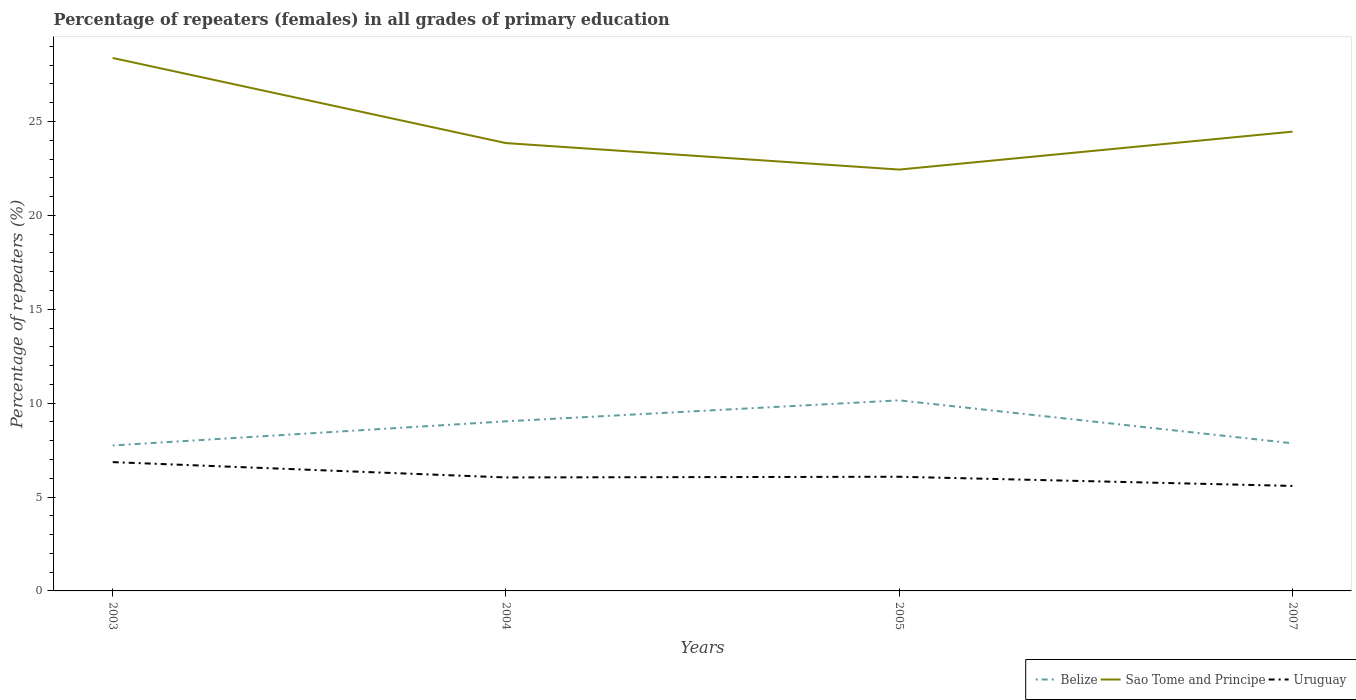How many different coloured lines are there?
Keep it short and to the point. 3. Is the number of lines equal to the number of legend labels?
Make the answer very short. Yes. Across all years, what is the maximum percentage of repeaters (females) in Sao Tome and Principe?
Give a very brief answer. 22.44. What is the total percentage of repeaters (females) in Belize in the graph?
Your response must be concise. -2.4. What is the difference between the highest and the second highest percentage of repeaters (females) in Sao Tome and Principe?
Keep it short and to the point. 5.94. What is the difference between the highest and the lowest percentage of repeaters (females) in Sao Tome and Principe?
Offer a very short reply. 1. Is the percentage of repeaters (females) in Sao Tome and Principe strictly greater than the percentage of repeaters (females) in Uruguay over the years?
Offer a terse response. No. How many lines are there?
Your answer should be very brief. 3. How many years are there in the graph?
Your response must be concise. 4. Does the graph contain any zero values?
Provide a short and direct response. No. Does the graph contain grids?
Offer a very short reply. No. Where does the legend appear in the graph?
Offer a terse response. Bottom right. How many legend labels are there?
Your response must be concise. 3. What is the title of the graph?
Keep it short and to the point. Percentage of repeaters (females) in all grades of primary education. Does "Armenia" appear as one of the legend labels in the graph?
Your answer should be very brief. No. What is the label or title of the X-axis?
Give a very brief answer. Years. What is the label or title of the Y-axis?
Offer a very short reply. Percentage of repeaters (%). What is the Percentage of repeaters (%) of Belize in 2003?
Provide a short and direct response. 7.75. What is the Percentage of repeaters (%) in Sao Tome and Principe in 2003?
Keep it short and to the point. 28.38. What is the Percentage of repeaters (%) of Uruguay in 2003?
Give a very brief answer. 6.86. What is the Percentage of repeaters (%) of Belize in 2004?
Offer a terse response. 9.03. What is the Percentage of repeaters (%) in Sao Tome and Principe in 2004?
Keep it short and to the point. 23.85. What is the Percentage of repeaters (%) of Uruguay in 2004?
Provide a succinct answer. 6.04. What is the Percentage of repeaters (%) in Belize in 2005?
Keep it short and to the point. 10.15. What is the Percentage of repeaters (%) in Sao Tome and Principe in 2005?
Your response must be concise. 22.44. What is the Percentage of repeaters (%) in Uruguay in 2005?
Your answer should be compact. 6.08. What is the Percentage of repeaters (%) of Belize in 2007?
Offer a very short reply. 7.86. What is the Percentage of repeaters (%) of Sao Tome and Principe in 2007?
Offer a terse response. 24.46. What is the Percentage of repeaters (%) in Uruguay in 2007?
Your answer should be compact. 5.59. Across all years, what is the maximum Percentage of repeaters (%) in Belize?
Ensure brevity in your answer.  10.15. Across all years, what is the maximum Percentage of repeaters (%) in Sao Tome and Principe?
Ensure brevity in your answer.  28.38. Across all years, what is the maximum Percentage of repeaters (%) in Uruguay?
Offer a terse response. 6.86. Across all years, what is the minimum Percentage of repeaters (%) of Belize?
Your answer should be very brief. 7.75. Across all years, what is the minimum Percentage of repeaters (%) of Sao Tome and Principe?
Offer a very short reply. 22.44. Across all years, what is the minimum Percentage of repeaters (%) of Uruguay?
Your answer should be compact. 5.59. What is the total Percentage of repeaters (%) of Belize in the graph?
Give a very brief answer. 34.79. What is the total Percentage of repeaters (%) in Sao Tome and Principe in the graph?
Provide a succinct answer. 99.13. What is the total Percentage of repeaters (%) in Uruguay in the graph?
Offer a very short reply. 24.57. What is the difference between the Percentage of repeaters (%) of Belize in 2003 and that in 2004?
Keep it short and to the point. -1.29. What is the difference between the Percentage of repeaters (%) in Sao Tome and Principe in 2003 and that in 2004?
Offer a terse response. 4.53. What is the difference between the Percentage of repeaters (%) in Uruguay in 2003 and that in 2004?
Offer a very short reply. 0.82. What is the difference between the Percentage of repeaters (%) in Belize in 2003 and that in 2005?
Keep it short and to the point. -2.4. What is the difference between the Percentage of repeaters (%) of Sao Tome and Principe in 2003 and that in 2005?
Ensure brevity in your answer.  5.94. What is the difference between the Percentage of repeaters (%) of Uruguay in 2003 and that in 2005?
Provide a short and direct response. 0.78. What is the difference between the Percentage of repeaters (%) in Belize in 2003 and that in 2007?
Your answer should be compact. -0.11. What is the difference between the Percentage of repeaters (%) of Sao Tome and Principe in 2003 and that in 2007?
Your answer should be very brief. 3.92. What is the difference between the Percentage of repeaters (%) of Uruguay in 2003 and that in 2007?
Provide a succinct answer. 1.27. What is the difference between the Percentage of repeaters (%) in Belize in 2004 and that in 2005?
Your answer should be compact. -1.12. What is the difference between the Percentage of repeaters (%) in Sao Tome and Principe in 2004 and that in 2005?
Ensure brevity in your answer.  1.41. What is the difference between the Percentage of repeaters (%) in Uruguay in 2004 and that in 2005?
Offer a terse response. -0.04. What is the difference between the Percentage of repeaters (%) in Belize in 2004 and that in 2007?
Keep it short and to the point. 1.17. What is the difference between the Percentage of repeaters (%) in Sao Tome and Principe in 2004 and that in 2007?
Offer a terse response. -0.61. What is the difference between the Percentage of repeaters (%) of Uruguay in 2004 and that in 2007?
Give a very brief answer. 0.45. What is the difference between the Percentage of repeaters (%) in Belize in 2005 and that in 2007?
Keep it short and to the point. 2.29. What is the difference between the Percentage of repeaters (%) in Sao Tome and Principe in 2005 and that in 2007?
Offer a very short reply. -2.02. What is the difference between the Percentage of repeaters (%) of Uruguay in 2005 and that in 2007?
Your answer should be very brief. 0.49. What is the difference between the Percentage of repeaters (%) of Belize in 2003 and the Percentage of repeaters (%) of Sao Tome and Principe in 2004?
Make the answer very short. -16.1. What is the difference between the Percentage of repeaters (%) of Belize in 2003 and the Percentage of repeaters (%) of Uruguay in 2004?
Make the answer very short. 1.7. What is the difference between the Percentage of repeaters (%) in Sao Tome and Principe in 2003 and the Percentage of repeaters (%) in Uruguay in 2004?
Ensure brevity in your answer.  22.34. What is the difference between the Percentage of repeaters (%) of Belize in 2003 and the Percentage of repeaters (%) of Sao Tome and Principe in 2005?
Provide a succinct answer. -14.69. What is the difference between the Percentage of repeaters (%) of Belize in 2003 and the Percentage of repeaters (%) of Uruguay in 2005?
Ensure brevity in your answer.  1.67. What is the difference between the Percentage of repeaters (%) in Sao Tome and Principe in 2003 and the Percentage of repeaters (%) in Uruguay in 2005?
Provide a succinct answer. 22.3. What is the difference between the Percentage of repeaters (%) in Belize in 2003 and the Percentage of repeaters (%) in Sao Tome and Principe in 2007?
Provide a succinct answer. -16.71. What is the difference between the Percentage of repeaters (%) of Belize in 2003 and the Percentage of repeaters (%) of Uruguay in 2007?
Provide a short and direct response. 2.15. What is the difference between the Percentage of repeaters (%) of Sao Tome and Principe in 2003 and the Percentage of repeaters (%) of Uruguay in 2007?
Your answer should be very brief. 22.79. What is the difference between the Percentage of repeaters (%) of Belize in 2004 and the Percentage of repeaters (%) of Sao Tome and Principe in 2005?
Your response must be concise. -13.41. What is the difference between the Percentage of repeaters (%) in Belize in 2004 and the Percentage of repeaters (%) in Uruguay in 2005?
Offer a terse response. 2.95. What is the difference between the Percentage of repeaters (%) of Sao Tome and Principe in 2004 and the Percentage of repeaters (%) of Uruguay in 2005?
Keep it short and to the point. 17.77. What is the difference between the Percentage of repeaters (%) of Belize in 2004 and the Percentage of repeaters (%) of Sao Tome and Principe in 2007?
Offer a very short reply. -15.43. What is the difference between the Percentage of repeaters (%) in Belize in 2004 and the Percentage of repeaters (%) in Uruguay in 2007?
Your response must be concise. 3.44. What is the difference between the Percentage of repeaters (%) of Sao Tome and Principe in 2004 and the Percentage of repeaters (%) of Uruguay in 2007?
Your response must be concise. 18.26. What is the difference between the Percentage of repeaters (%) of Belize in 2005 and the Percentage of repeaters (%) of Sao Tome and Principe in 2007?
Make the answer very short. -14.31. What is the difference between the Percentage of repeaters (%) of Belize in 2005 and the Percentage of repeaters (%) of Uruguay in 2007?
Your answer should be very brief. 4.56. What is the difference between the Percentage of repeaters (%) of Sao Tome and Principe in 2005 and the Percentage of repeaters (%) of Uruguay in 2007?
Your response must be concise. 16.85. What is the average Percentage of repeaters (%) of Belize per year?
Make the answer very short. 8.7. What is the average Percentage of repeaters (%) of Sao Tome and Principe per year?
Provide a short and direct response. 24.78. What is the average Percentage of repeaters (%) of Uruguay per year?
Provide a succinct answer. 6.14. In the year 2003, what is the difference between the Percentage of repeaters (%) of Belize and Percentage of repeaters (%) of Sao Tome and Principe?
Ensure brevity in your answer.  -20.64. In the year 2003, what is the difference between the Percentage of repeaters (%) in Belize and Percentage of repeaters (%) in Uruguay?
Your answer should be compact. 0.89. In the year 2003, what is the difference between the Percentage of repeaters (%) in Sao Tome and Principe and Percentage of repeaters (%) in Uruguay?
Keep it short and to the point. 21.52. In the year 2004, what is the difference between the Percentage of repeaters (%) in Belize and Percentage of repeaters (%) in Sao Tome and Principe?
Your answer should be very brief. -14.82. In the year 2004, what is the difference between the Percentage of repeaters (%) of Belize and Percentage of repeaters (%) of Uruguay?
Keep it short and to the point. 2.99. In the year 2004, what is the difference between the Percentage of repeaters (%) in Sao Tome and Principe and Percentage of repeaters (%) in Uruguay?
Offer a terse response. 17.81. In the year 2005, what is the difference between the Percentage of repeaters (%) in Belize and Percentage of repeaters (%) in Sao Tome and Principe?
Keep it short and to the point. -12.29. In the year 2005, what is the difference between the Percentage of repeaters (%) in Belize and Percentage of repeaters (%) in Uruguay?
Offer a very short reply. 4.07. In the year 2005, what is the difference between the Percentage of repeaters (%) in Sao Tome and Principe and Percentage of repeaters (%) in Uruguay?
Offer a terse response. 16.36. In the year 2007, what is the difference between the Percentage of repeaters (%) in Belize and Percentage of repeaters (%) in Sao Tome and Principe?
Your answer should be very brief. -16.6. In the year 2007, what is the difference between the Percentage of repeaters (%) in Belize and Percentage of repeaters (%) in Uruguay?
Make the answer very short. 2.27. In the year 2007, what is the difference between the Percentage of repeaters (%) of Sao Tome and Principe and Percentage of repeaters (%) of Uruguay?
Give a very brief answer. 18.87. What is the ratio of the Percentage of repeaters (%) of Belize in 2003 to that in 2004?
Ensure brevity in your answer.  0.86. What is the ratio of the Percentage of repeaters (%) in Sao Tome and Principe in 2003 to that in 2004?
Give a very brief answer. 1.19. What is the ratio of the Percentage of repeaters (%) of Uruguay in 2003 to that in 2004?
Offer a terse response. 1.14. What is the ratio of the Percentage of repeaters (%) in Belize in 2003 to that in 2005?
Ensure brevity in your answer.  0.76. What is the ratio of the Percentage of repeaters (%) of Sao Tome and Principe in 2003 to that in 2005?
Offer a very short reply. 1.26. What is the ratio of the Percentage of repeaters (%) in Uruguay in 2003 to that in 2005?
Give a very brief answer. 1.13. What is the ratio of the Percentage of repeaters (%) in Belize in 2003 to that in 2007?
Provide a short and direct response. 0.99. What is the ratio of the Percentage of repeaters (%) in Sao Tome and Principe in 2003 to that in 2007?
Give a very brief answer. 1.16. What is the ratio of the Percentage of repeaters (%) of Uruguay in 2003 to that in 2007?
Make the answer very short. 1.23. What is the ratio of the Percentage of repeaters (%) of Belize in 2004 to that in 2005?
Your response must be concise. 0.89. What is the ratio of the Percentage of repeaters (%) of Sao Tome and Principe in 2004 to that in 2005?
Your answer should be very brief. 1.06. What is the ratio of the Percentage of repeaters (%) in Belize in 2004 to that in 2007?
Ensure brevity in your answer.  1.15. What is the ratio of the Percentage of repeaters (%) of Uruguay in 2004 to that in 2007?
Your answer should be very brief. 1.08. What is the ratio of the Percentage of repeaters (%) of Belize in 2005 to that in 2007?
Ensure brevity in your answer.  1.29. What is the ratio of the Percentage of repeaters (%) of Sao Tome and Principe in 2005 to that in 2007?
Offer a very short reply. 0.92. What is the ratio of the Percentage of repeaters (%) in Uruguay in 2005 to that in 2007?
Offer a very short reply. 1.09. What is the difference between the highest and the second highest Percentage of repeaters (%) of Belize?
Offer a very short reply. 1.12. What is the difference between the highest and the second highest Percentage of repeaters (%) in Sao Tome and Principe?
Offer a very short reply. 3.92. What is the difference between the highest and the second highest Percentage of repeaters (%) in Uruguay?
Offer a very short reply. 0.78. What is the difference between the highest and the lowest Percentage of repeaters (%) in Belize?
Provide a succinct answer. 2.4. What is the difference between the highest and the lowest Percentage of repeaters (%) in Sao Tome and Principe?
Your response must be concise. 5.94. What is the difference between the highest and the lowest Percentage of repeaters (%) in Uruguay?
Offer a very short reply. 1.27. 